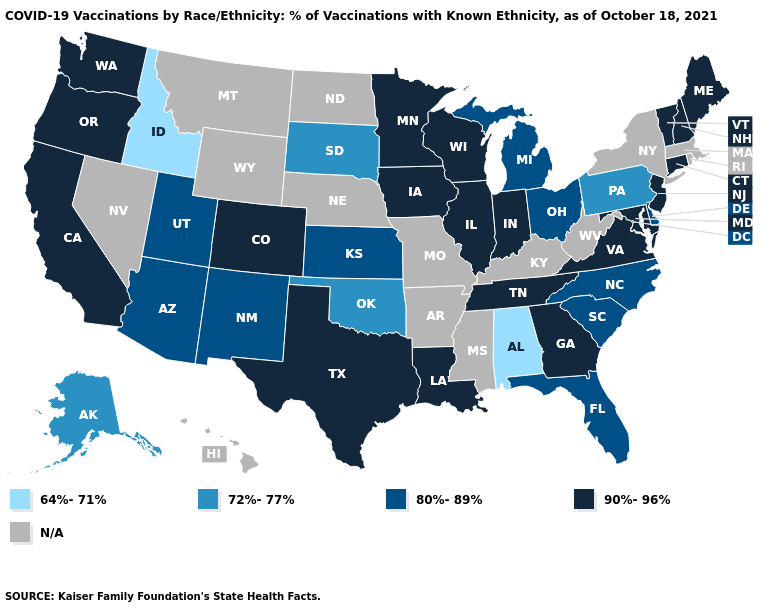What is the value of Oregon?
Write a very short answer. 90%-96%. Does Alabama have the highest value in the South?
Write a very short answer. No. Does the first symbol in the legend represent the smallest category?
Short answer required. Yes. Is the legend a continuous bar?
Keep it brief. No. Which states hav the highest value in the MidWest?
Answer briefly. Illinois, Indiana, Iowa, Minnesota, Wisconsin. What is the value of Wisconsin?
Write a very short answer. 90%-96%. Name the states that have a value in the range 80%-89%?
Answer briefly. Arizona, Delaware, Florida, Kansas, Michigan, New Mexico, North Carolina, Ohio, South Carolina, Utah. What is the value of Oklahoma?
Quick response, please. 72%-77%. Name the states that have a value in the range N/A?
Write a very short answer. Arkansas, Hawaii, Kentucky, Massachusetts, Mississippi, Missouri, Montana, Nebraska, Nevada, New York, North Dakota, Rhode Island, West Virginia, Wyoming. Among the states that border Massachusetts , which have the highest value?
Concise answer only. Connecticut, New Hampshire, Vermont. Which states have the lowest value in the West?
Concise answer only. Idaho. Which states have the lowest value in the USA?
Quick response, please. Alabama, Idaho. Name the states that have a value in the range 64%-71%?
Answer briefly. Alabama, Idaho. Name the states that have a value in the range 80%-89%?
Give a very brief answer. Arizona, Delaware, Florida, Kansas, Michigan, New Mexico, North Carolina, Ohio, South Carolina, Utah. Name the states that have a value in the range 90%-96%?
Concise answer only. California, Colorado, Connecticut, Georgia, Illinois, Indiana, Iowa, Louisiana, Maine, Maryland, Minnesota, New Hampshire, New Jersey, Oregon, Tennessee, Texas, Vermont, Virginia, Washington, Wisconsin. 